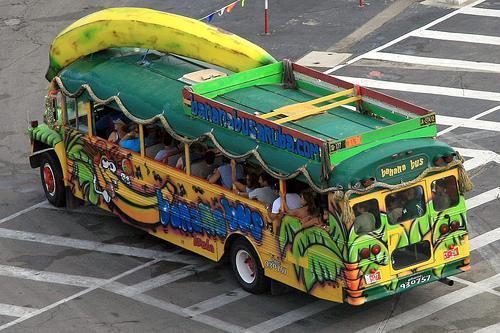How many large bananas are on the bus?
Give a very brief answer. 1. 